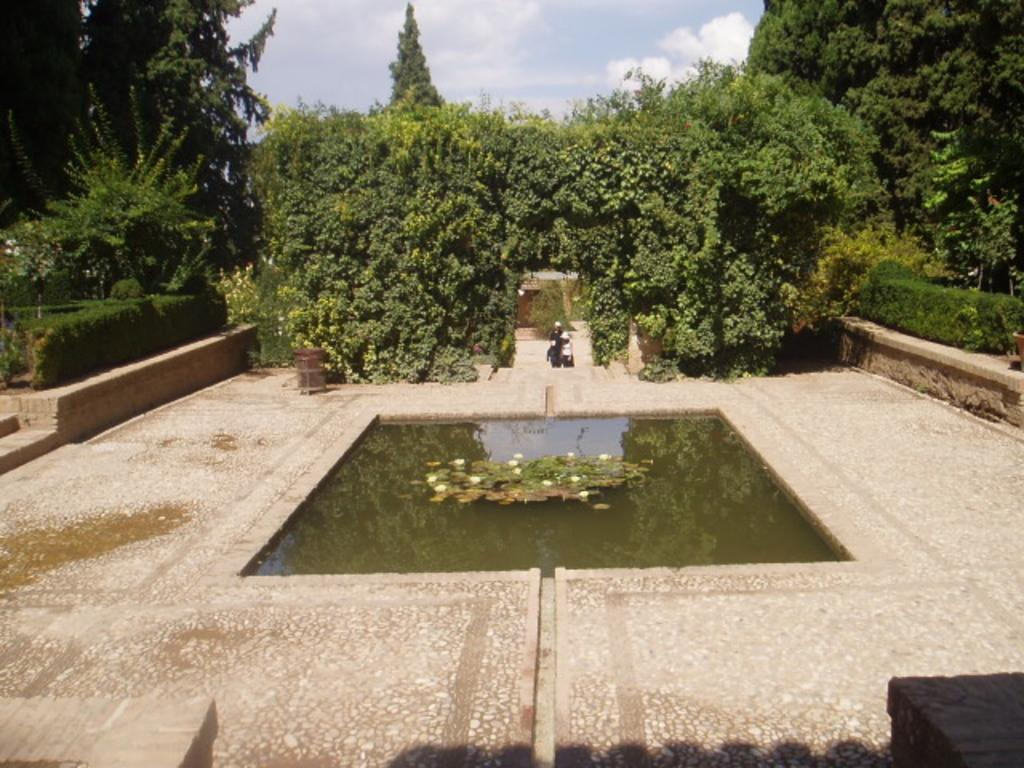What type of vegetation can be seen in the image? There are trees in the image. What else can be seen besides the trees? There is water visible in the image, as well as a path. Can you describe the person in the image? There is a person in the image, but their appearance or actions are not specified. What is visible in the background of the image? The sky is visible in the background of the image, and there are clouds in the sky. How many trucks are parked along the path in the image? There are no trucks present in the image; it features trees, water, a path, a person, and a sky with clouds. What point is the person trying to make in the image? There is no indication of the person's intentions or actions in the image, so it is not possible to determine what point they might be trying to make. 